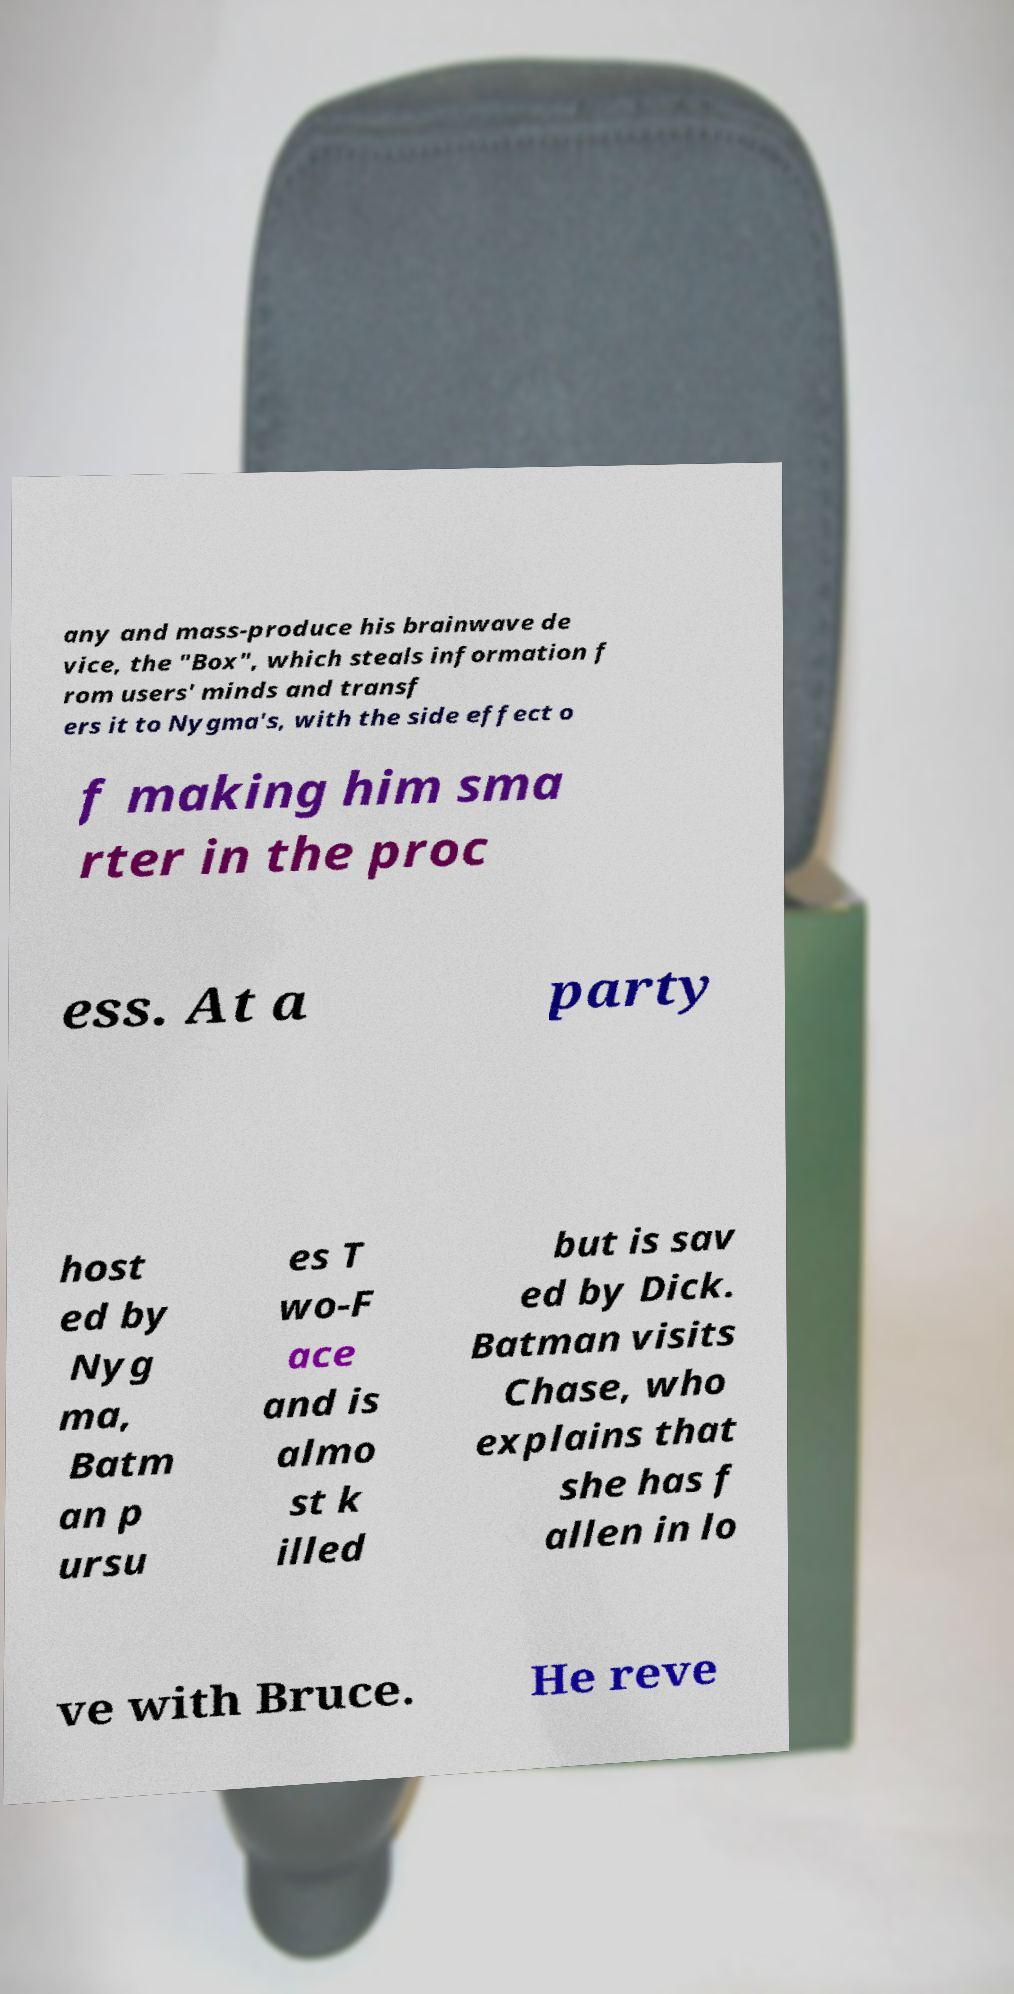What messages or text are displayed in this image? I need them in a readable, typed format. any and mass-produce his brainwave de vice, the "Box", which steals information f rom users' minds and transf ers it to Nygma's, with the side effect o f making him sma rter in the proc ess. At a party host ed by Nyg ma, Batm an p ursu es T wo-F ace and is almo st k illed but is sav ed by Dick. Batman visits Chase, who explains that she has f allen in lo ve with Bruce. He reve 